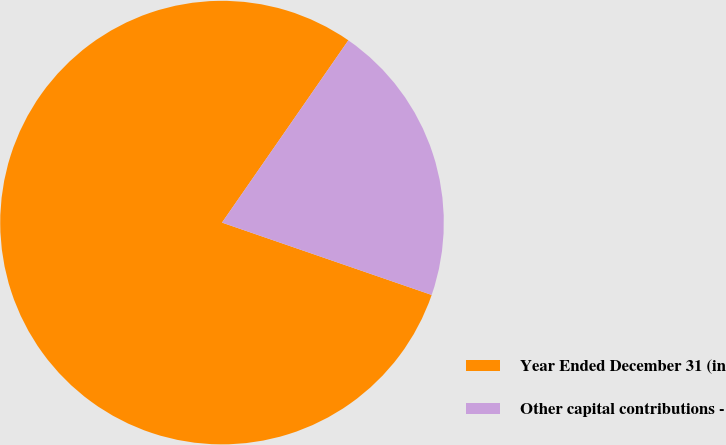Convert chart. <chart><loc_0><loc_0><loc_500><loc_500><pie_chart><fcel>Year Ended December 31 (in<fcel>Other capital contributions -<nl><fcel>79.36%<fcel>20.64%<nl></chart> 